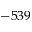<formula> <loc_0><loc_0><loc_500><loc_500>- 5 3 9</formula> 